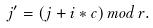<formula> <loc_0><loc_0><loc_500><loc_500>j ^ { \prime } = ( j + i * c ) \, m o d \, r .</formula> 